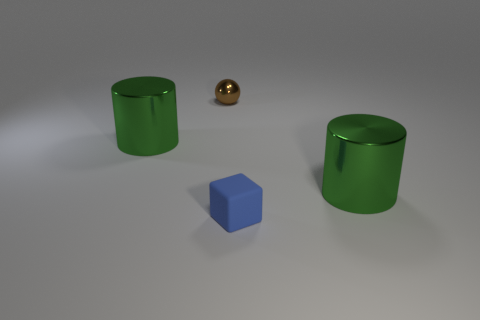Is the number of brown spheres behind the brown object less than the number of big green metallic objects?
Offer a very short reply. Yes. The ball that is the same size as the blue object is what color?
Offer a terse response. Brown. What is the color of the cylinder to the left of the small blue cube?
Give a very brief answer. Green. How many metal objects are either small cylinders or green cylinders?
Keep it short and to the point. 2. How many shiny balls have the same size as the rubber block?
Your response must be concise. 1. There is a object that is both to the right of the brown thing and behind the tiny blue rubber object; what is its color?
Your answer should be compact. Green. How many things are small purple metallic objects or rubber blocks?
Offer a very short reply. 1. How many large objects are green metallic cylinders or brown metal balls?
Your response must be concise. 2. Is there anything else that has the same color as the rubber thing?
Your response must be concise. No. What size is the shiny thing that is both left of the small matte thing and in front of the tiny brown object?
Keep it short and to the point. Large. 